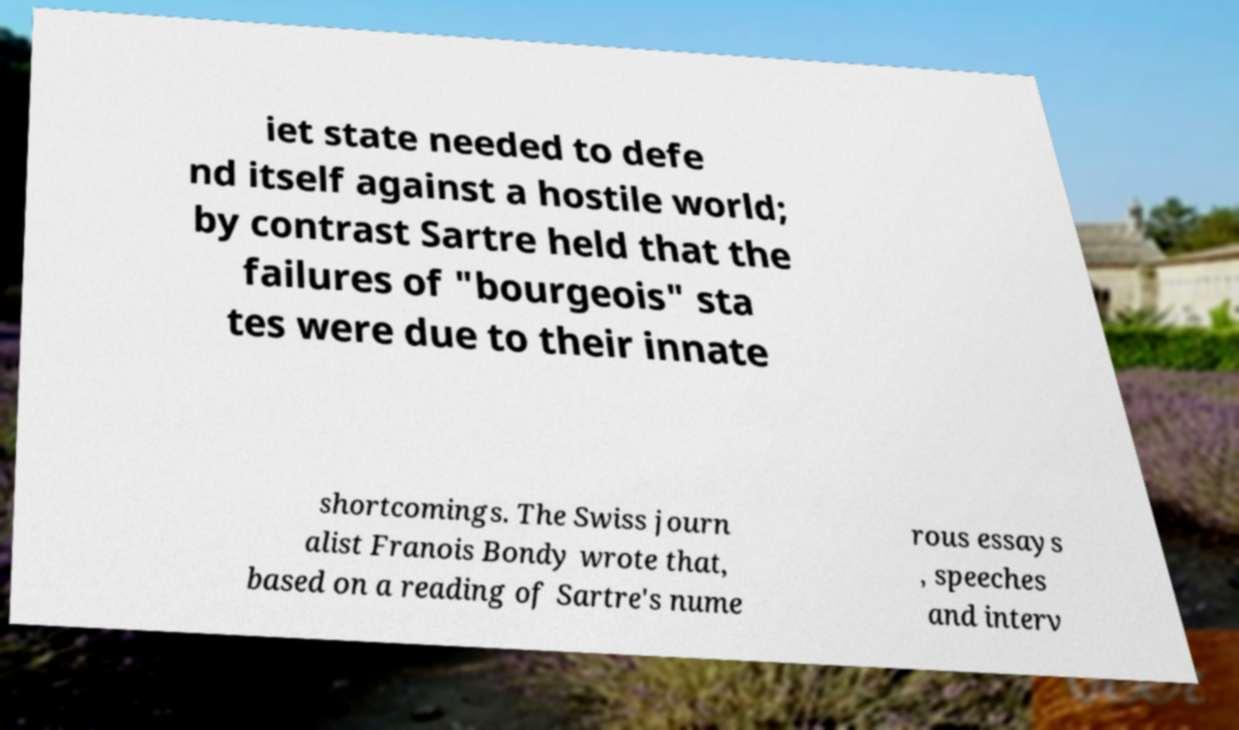Could you extract and type out the text from this image? iet state needed to defe nd itself against a hostile world; by contrast Sartre held that the failures of "bourgeois" sta tes were due to their innate shortcomings. The Swiss journ alist Franois Bondy wrote that, based on a reading of Sartre's nume rous essays , speeches and interv 